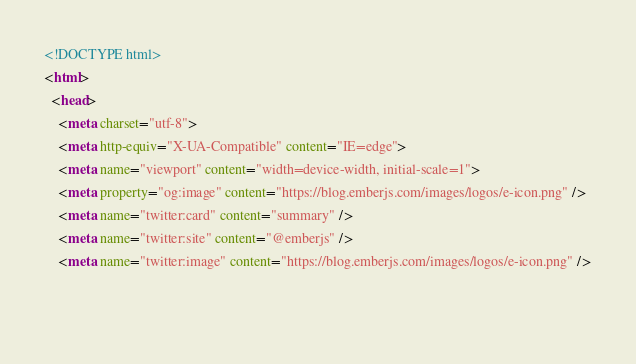<code> <loc_0><loc_0><loc_500><loc_500><_HTML_><!DOCTYPE html>
<html>
  <head>
    <meta charset="utf-8">
    <meta http-equiv="X-UA-Compatible" content="IE=edge">
    <meta name="viewport" content="width=device-width, initial-scale=1">
    <meta property="og:image" content="https://blog.emberjs.com/images/logos/e-icon.png" />
    <meta name="twitter:card" content="summary" />
    <meta name="twitter:site" content="@emberjs" />
    <meta name="twitter:image" content="https://blog.emberjs.com/images/logos/e-icon.png" />

    </code> 